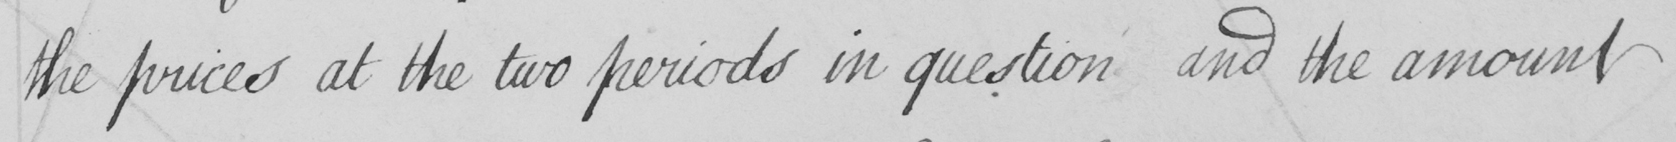Can you read and transcribe this handwriting? the prices at the two periods in question and the amount 